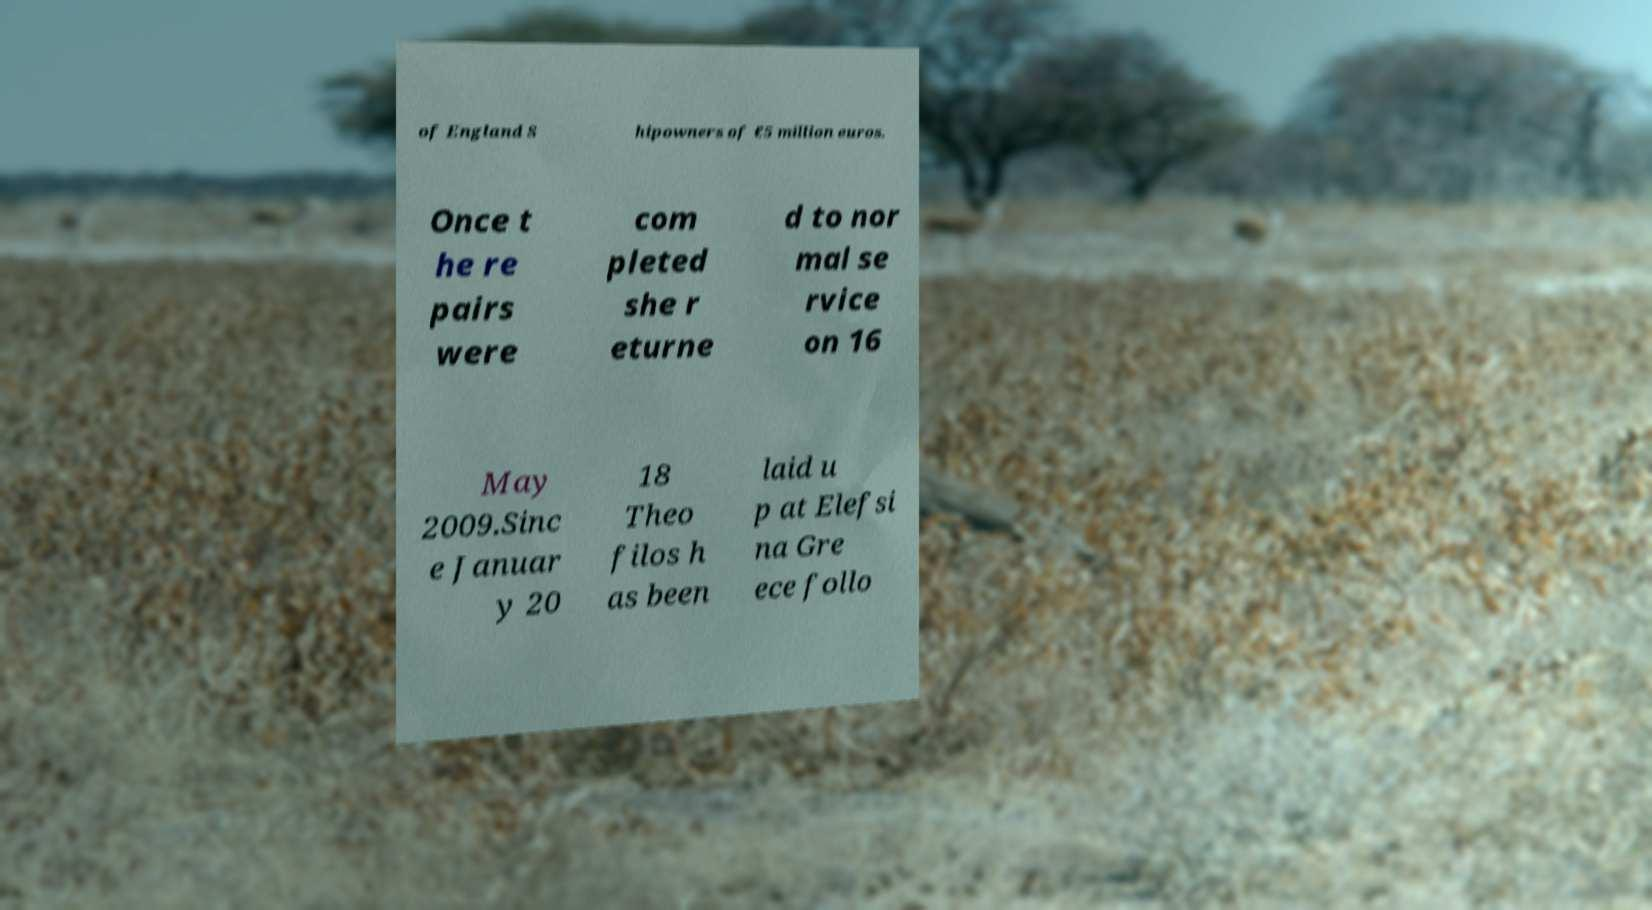For documentation purposes, I need the text within this image transcribed. Could you provide that? of England S hipowners of €5 million euros. Once t he re pairs were com pleted she r eturne d to nor mal se rvice on 16 May 2009.Sinc e Januar y 20 18 Theo filos h as been laid u p at Elefsi na Gre ece follo 